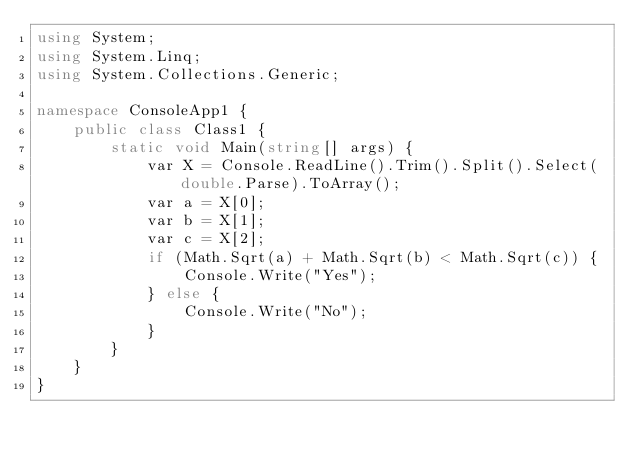<code> <loc_0><loc_0><loc_500><loc_500><_C#_>using System;
using System.Linq;
using System.Collections.Generic;

namespace ConsoleApp1 {
    public class Class1 {
        static void Main(string[] args) {
            var X = Console.ReadLine().Trim().Split().Select(double.Parse).ToArray();
            var a = X[0];
            var b = X[1];
            var c = X[2];
            if (Math.Sqrt(a) + Math.Sqrt(b) < Math.Sqrt(c)) {
                Console.Write("Yes");
            } else {
                Console.Write("No");
            }
        }
    }
}</code> 